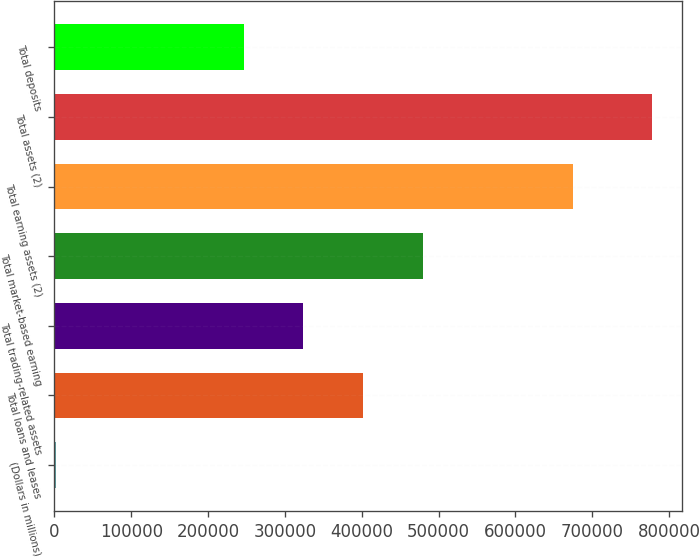<chart> <loc_0><loc_0><loc_500><loc_500><bar_chart><fcel>(Dollars in millions)<fcel>Total loans and leases<fcel>Total trading-related assets<fcel>Total market-based earning<fcel>Total earning assets (2)<fcel>Total assets (2)<fcel>Total deposits<nl><fcel>2007<fcel>401472<fcel>323857<fcel>479087<fcel>675407<fcel>778158<fcel>246242<nl></chart> 